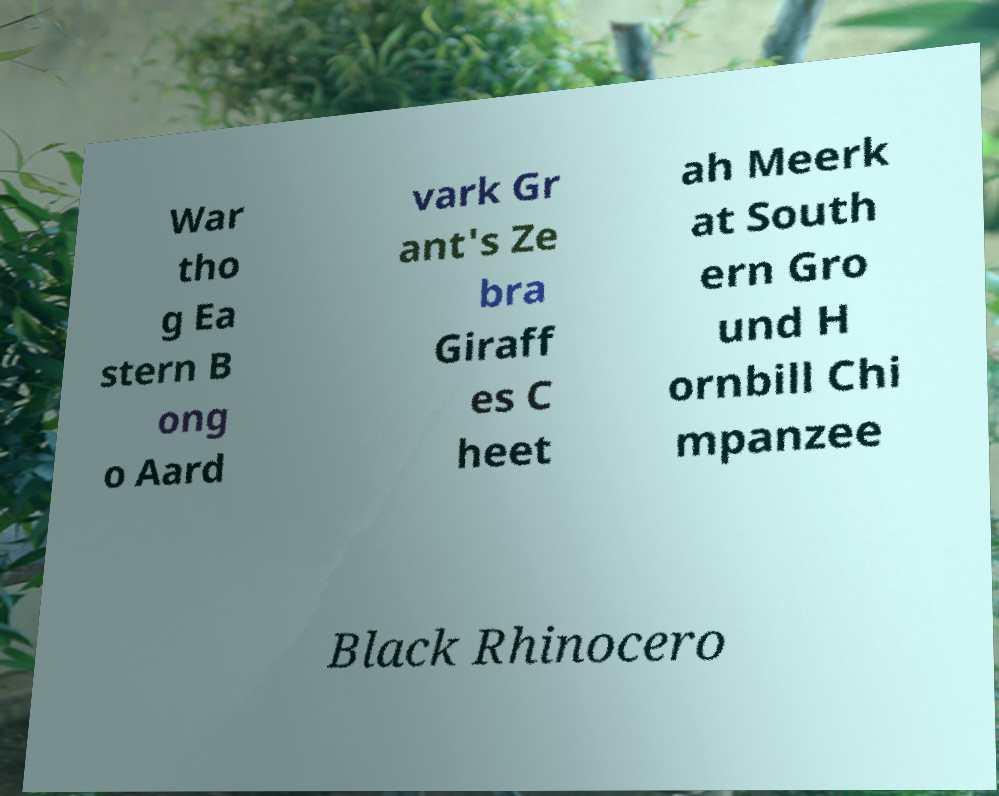What messages or text are displayed in this image? I need them in a readable, typed format. War tho g Ea stern B ong o Aard vark Gr ant's Ze bra Giraff es C heet ah Meerk at South ern Gro und H ornbill Chi mpanzee Black Rhinocero 